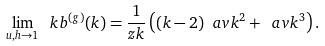Convert formula to latex. <formula><loc_0><loc_0><loc_500><loc_500>\lim _ { u , h \rightarrow 1 } \ k b ^ { ( g ) } ( k ) = \frac { 1 } { z k } \left ( ( k - 2 ) \ a v { k ^ { 2 } } + \ a v { k ^ { 3 } } \right ) .</formula> 